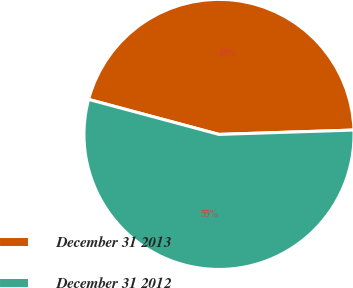Convert chart to OTSL. <chart><loc_0><loc_0><loc_500><loc_500><pie_chart><fcel>December 31 2013<fcel>December 31 2012<nl><fcel>45.31%<fcel>54.69%<nl></chart> 